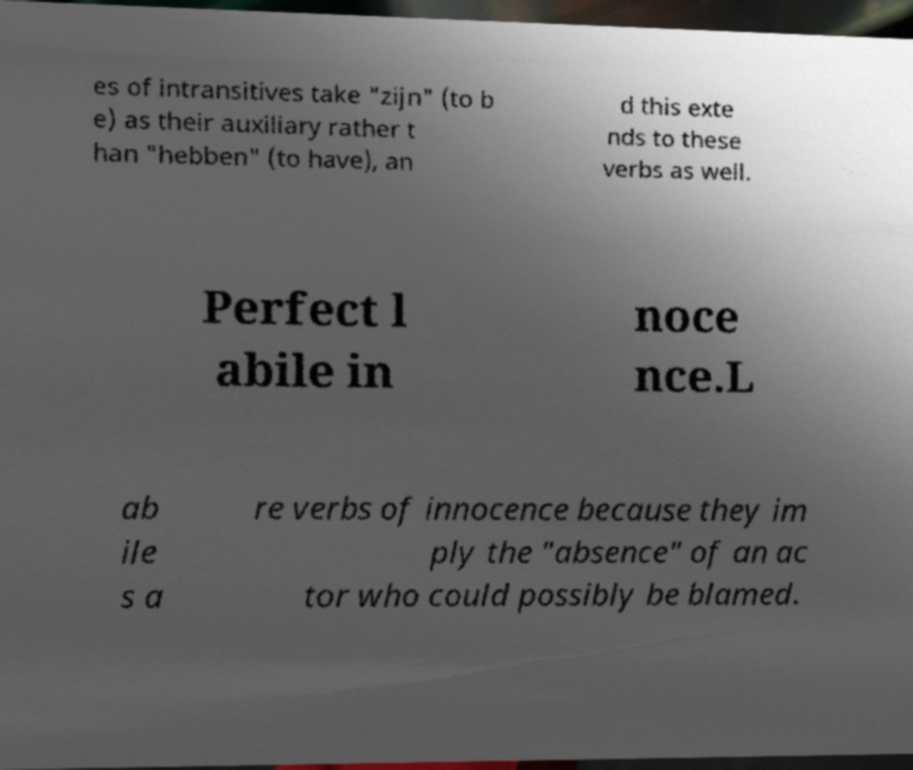Can you read and provide the text displayed in the image?This photo seems to have some interesting text. Can you extract and type it out for me? es of intransitives take "zijn" (to b e) as their auxiliary rather t han "hebben" (to have), an d this exte nds to these verbs as well. Perfect l abile in noce nce.L ab ile s a re verbs of innocence because they im ply the "absence" of an ac tor who could possibly be blamed. 